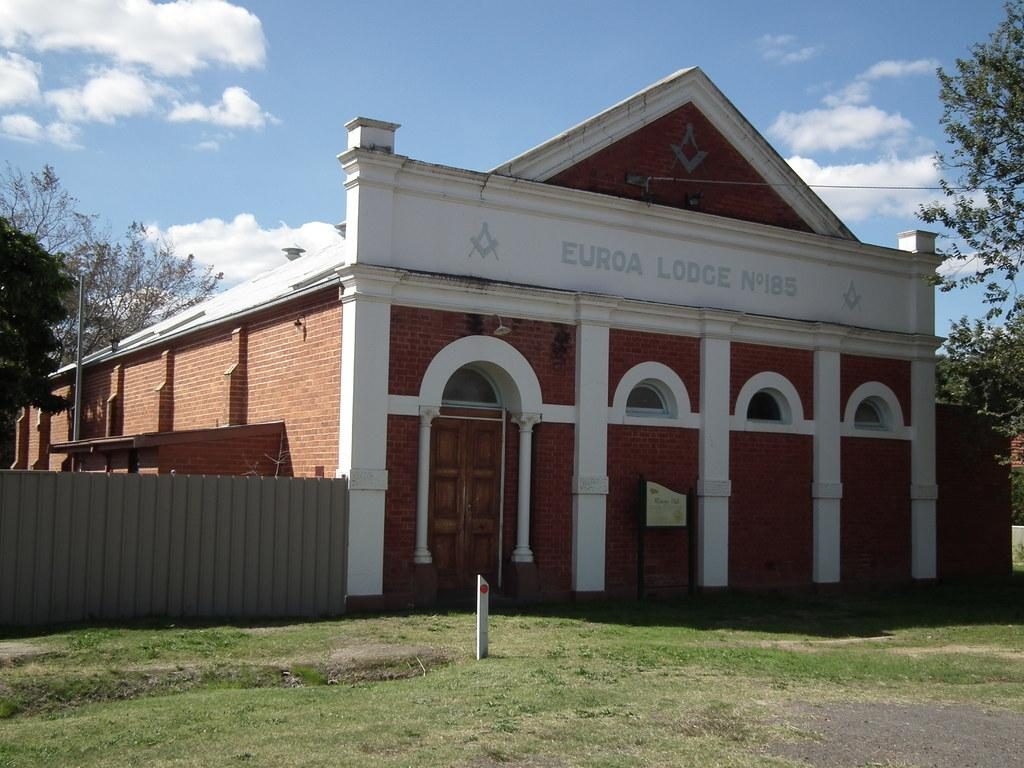What is one of the main structures in the image? There is a pole in the image. What type of terrain is visible in the image? Grass is present on the ground in the image. What type of man-made structure can be seen in the image? There is a building in the image. How many doors are visible in the image? There are doors in the image. What type of barrier is present in the image? There is a fence in the image. What type of vegetation is visible in the image? Trees are visible in the image. How many poles are visible in the image? There are poles in the image. What is visible in the sky in the image? Clouds are present in the sky in the image. What type of store can be seen in the image? There is no store present in the image. How many drops of rain can be seen falling from the sky in the image? There are no drops of rain visible in the image; only clouds are present in the sky. 